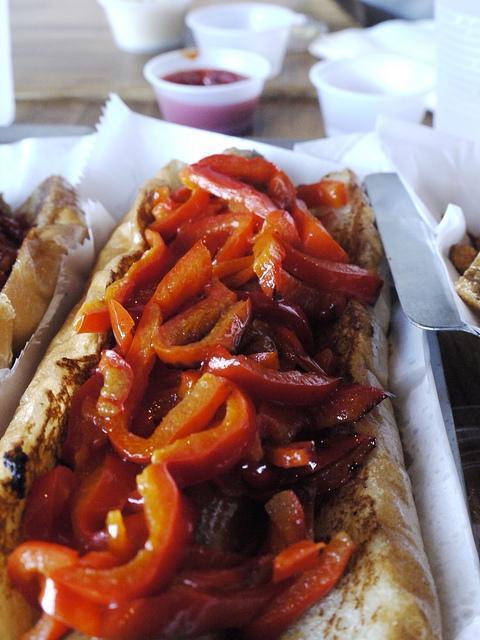What is on top of the sandwich?
Make your selection and explain in format: 'Answer: answer
Rationale: rationale.'
Options: Tater tots, red peppers, mustard, eggs. Answer: red peppers.
Rationale: There are sliced vegetables on top of the sandwich. 